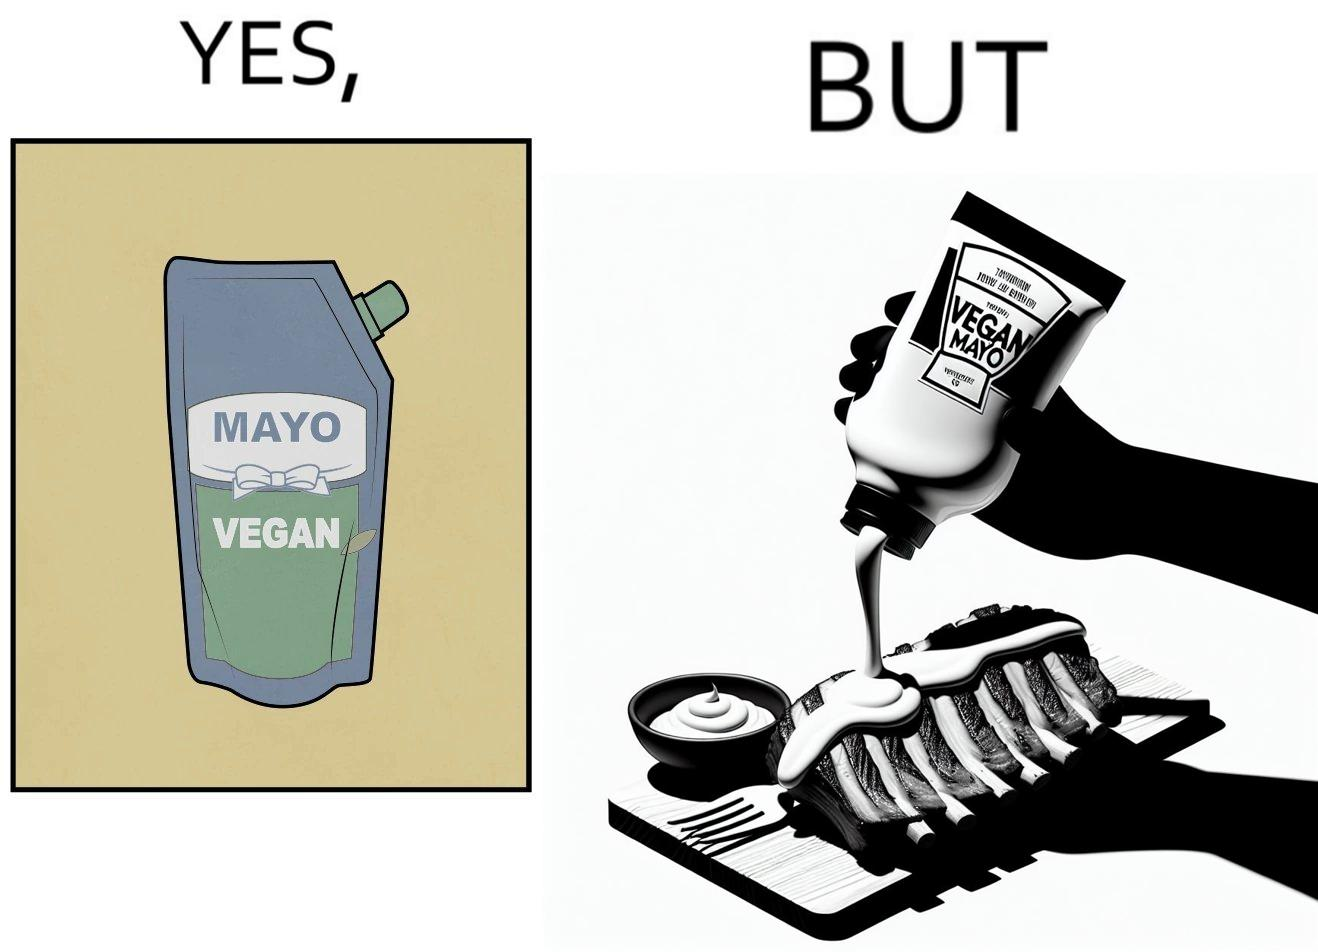What is shown in this image? The image is ironical, as vegan mayo sauce is being poured on rib steak, which is non-vegetarian. The person might as well just use normal mayo sauce instead. 